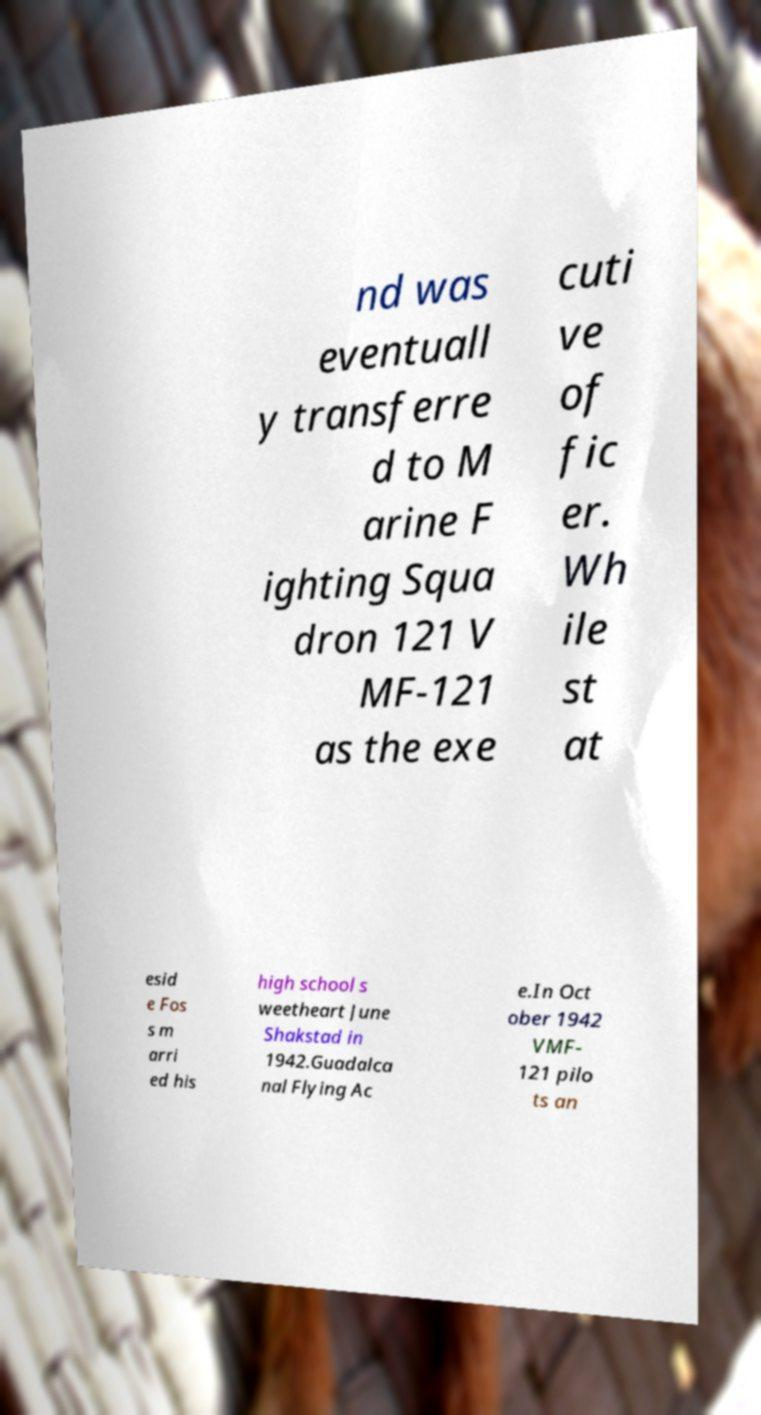What messages or text are displayed in this image? I need them in a readable, typed format. nd was eventuall y transferre d to M arine F ighting Squa dron 121 V MF-121 as the exe cuti ve of fic er. Wh ile st at esid e Fos s m arri ed his high school s weetheart June Shakstad in 1942.Guadalca nal Flying Ac e.In Oct ober 1942 VMF- 121 pilo ts an 